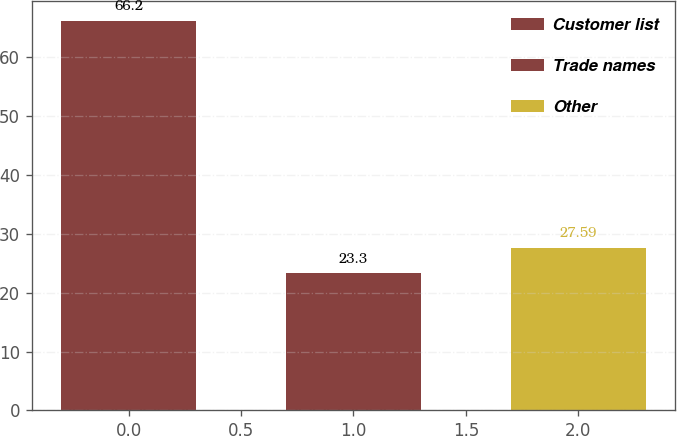<chart> <loc_0><loc_0><loc_500><loc_500><bar_chart><fcel>Customer list<fcel>Trade names<fcel>Other<nl><fcel>66.2<fcel>23.3<fcel>27.59<nl></chart> 